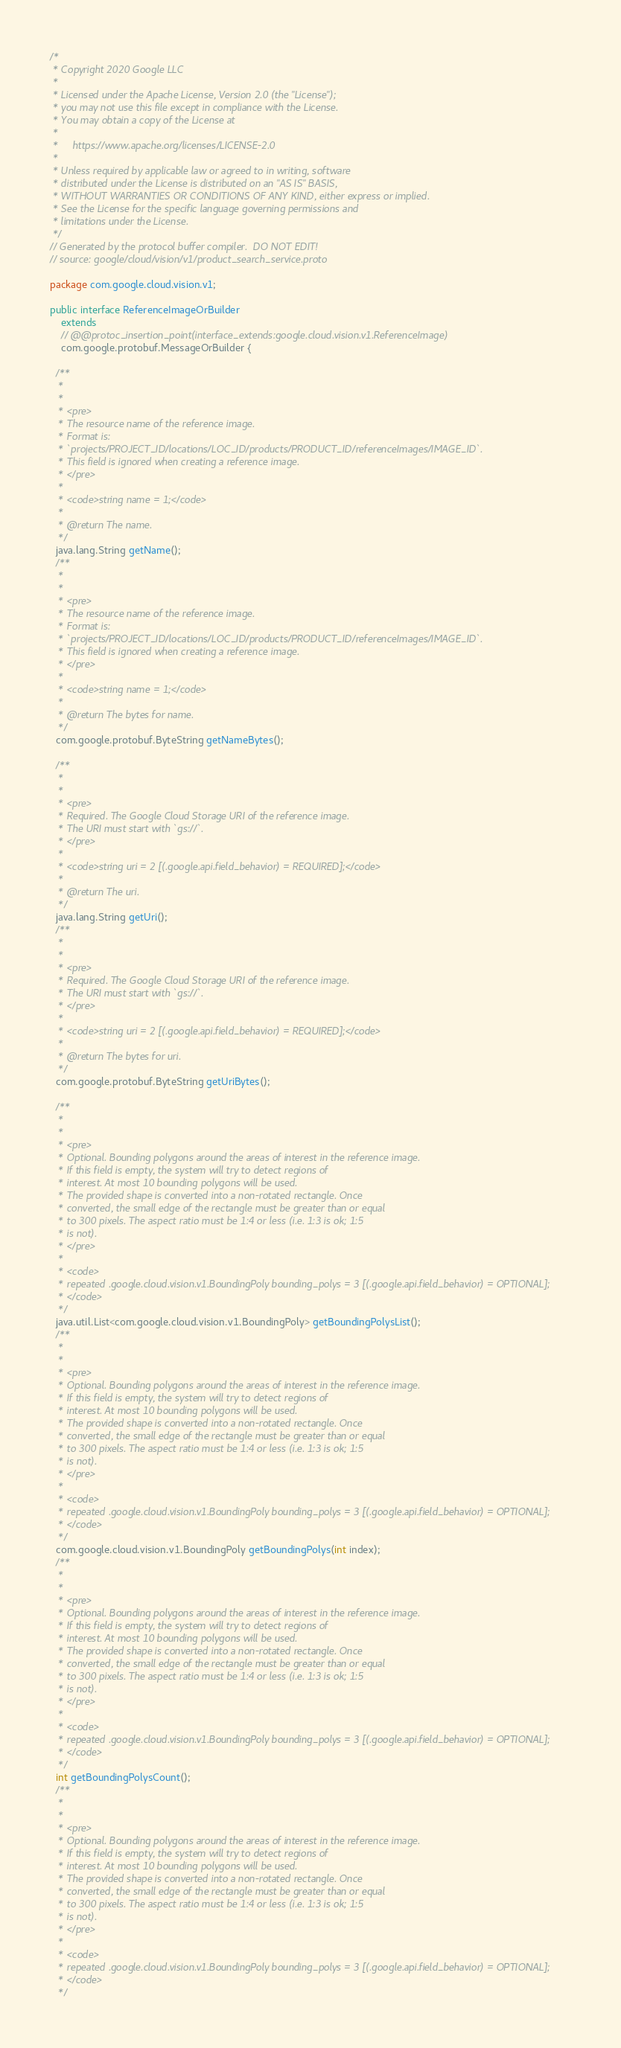Convert code to text. <code><loc_0><loc_0><loc_500><loc_500><_Java_>/*
 * Copyright 2020 Google LLC
 *
 * Licensed under the Apache License, Version 2.0 (the "License");
 * you may not use this file except in compliance with the License.
 * You may obtain a copy of the License at
 *
 *     https://www.apache.org/licenses/LICENSE-2.0
 *
 * Unless required by applicable law or agreed to in writing, software
 * distributed under the License is distributed on an "AS IS" BASIS,
 * WITHOUT WARRANTIES OR CONDITIONS OF ANY KIND, either express or implied.
 * See the License for the specific language governing permissions and
 * limitations under the License.
 */
// Generated by the protocol buffer compiler.  DO NOT EDIT!
// source: google/cloud/vision/v1/product_search_service.proto

package com.google.cloud.vision.v1;

public interface ReferenceImageOrBuilder
    extends
    // @@protoc_insertion_point(interface_extends:google.cloud.vision.v1.ReferenceImage)
    com.google.protobuf.MessageOrBuilder {

  /**
   *
   *
   * <pre>
   * The resource name of the reference image.
   * Format is:
   * `projects/PROJECT_ID/locations/LOC_ID/products/PRODUCT_ID/referenceImages/IMAGE_ID`.
   * This field is ignored when creating a reference image.
   * </pre>
   *
   * <code>string name = 1;</code>
   *
   * @return The name.
   */
  java.lang.String getName();
  /**
   *
   *
   * <pre>
   * The resource name of the reference image.
   * Format is:
   * `projects/PROJECT_ID/locations/LOC_ID/products/PRODUCT_ID/referenceImages/IMAGE_ID`.
   * This field is ignored when creating a reference image.
   * </pre>
   *
   * <code>string name = 1;</code>
   *
   * @return The bytes for name.
   */
  com.google.protobuf.ByteString getNameBytes();

  /**
   *
   *
   * <pre>
   * Required. The Google Cloud Storage URI of the reference image.
   * The URI must start with `gs://`.
   * </pre>
   *
   * <code>string uri = 2 [(.google.api.field_behavior) = REQUIRED];</code>
   *
   * @return The uri.
   */
  java.lang.String getUri();
  /**
   *
   *
   * <pre>
   * Required. The Google Cloud Storage URI of the reference image.
   * The URI must start with `gs://`.
   * </pre>
   *
   * <code>string uri = 2 [(.google.api.field_behavior) = REQUIRED];</code>
   *
   * @return The bytes for uri.
   */
  com.google.protobuf.ByteString getUriBytes();

  /**
   *
   *
   * <pre>
   * Optional. Bounding polygons around the areas of interest in the reference image.
   * If this field is empty, the system will try to detect regions of
   * interest. At most 10 bounding polygons will be used.
   * The provided shape is converted into a non-rotated rectangle. Once
   * converted, the small edge of the rectangle must be greater than or equal
   * to 300 pixels. The aspect ratio must be 1:4 or less (i.e. 1:3 is ok; 1:5
   * is not).
   * </pre>
   *
   * <code>
   * repeated .google.cloud.vision.v1.BoundingPoly bounding_polys = 3 [(.google.api.field_behavior) = OPTIONAL];
   * </code>
   */
  java.util.List<com.google.cloud.vision.v1.BoundingPoly> getBoundingPolysList();
  /**
   *
   *
   * <pre>
   * Optional. Bounding polygons around the areas of interest in the reference image.
   * If this field is empty, the system will try to detect regions of
   * interest. At most 10 bounding polygons will be used.
   * The provided shape is converted into a non-rotated rectangle. Once
   * converted, the small edge of the rectangle must be greater than or equal
   * to 300 pixels. The aspect ratio must be 1:4 or less (i.e. 1:3 is ok; 1:5
   * is not).
   * </pre>
   *
   * <code>
   * repeated .google.cloud.vision.v1.BoundingPoly bounding_polys = 3 [(.google.api.field_behavior) = OPTIONAL];
   * </code>
   */
  com.google.cloud.vision.v1.BoundingPoly getBoundingPolys(int index);
  /**
   *
   *
   * <pre>
   * Optional. Bounding polygons around the areas of interest in the reference image.
   * If this field is empty, the system will try to detect regions of
   * interest. At most 10 bounding polygons will be used.
   * The provided shape is converted into a non-rotated rectangle. Once
   * converted, the small edge of the rectangle must be greater than or equal
   * to 300 pixels. The aspect ratio must be 1:4 or less (i.e. 1:3 is ok; 1:5
   * is not).
   * </pre>
   *
   * <code>
   * repeated .google.cloud.vision.v1.BoundingPoly bounding_polys = 3 [(.google.api.field_behavior) = OPTIONAL];
   * </code>
   */
  int getBoundingPolysCount();
  /**
   *
   *
   * <pre>
   * Optional. Bounding polygons around the areas of interest in the reference image.
   * If this field is empty, the system will try to detect regions of
   * interest. At most 10 bounding polygons will be used.
   * The provided shape is converted into a non-rotated rectangle. Once
   * converted, the small edge of the rectangle must be greater than or equal
   * to 300 pixels. The aspect ratio must be 1:4 or less (i.e. 1:3 is ok; 1:5
   * is not).
   * </pre>
   *
   * <code>
   * repeated .google.cloud.vision.v1.BoundingPoly bounding_polys = 3 [(.google.api.field_behavior) = OPTIONAL];
   * </code>
   */</code> 